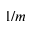<formula> <loc_0><loc_0><loc_500><loc_500>1 / m</formula> 